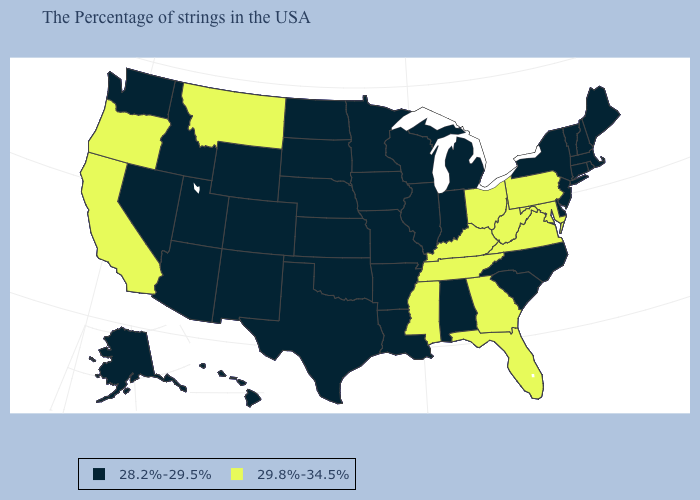What is the value of Nebraska?
Write a very short answer. 28.2%-29.5%. Among the states that border South Dakota , does Montana have the highest value?
Write a very short answer. Yes. Does Pennsylvania have the lowest value in the Northeast?
Give a very brief answer. No. Does Arizona have the highest value in the USA?
Short answer required. No. Among the states that border Florida , does Alabama have the lowest value?
Quick response, please. Yes. What is the value of Delaware?
Be succinct. 28.2%-29.5%. What is the value of Montana?
Give a very brief answer. 29.8%-34.5%. Name the states that have a value in the range 28.2%-29.5%?
Write a very short answer. Maine, Massachusetts, Rhode Island, New Hampshire, Vermont, Connecticut, New York, New Jersey, Delaware, North Carolina, South Carolina, Michigan, Indiana, Alabama, Wisconsin, Illinois, Louisiana, Missouri, Arkansas, Minnesota, Iowa, Kansas, Nebraska, Oklahoma, Texas, South Dakota, North Dakota, Wyoming, Colorado, New Mexico, Utah, Arizona, Idaho, Nevada, Washington, Alaska, Hawaii. Does South Carolina have the highest value in the USA?
Answer briefly. No. Name the states that have a value in the range 29.8%-34.5%?
Short answer required. Maryland, Pennsylvania, Virginia, West Virginia, Ohio, Florida, Georgia, Kentucky, Tennessee, Mississippi, Montana, California, Oregon. Name the states that have a value in the range 28.2%-29.5%?
Write a very short answer. Maine, Massachusetts, Rhode Island, New Hampshire, Vermont, Connecticut, New York, New Jersey, Delaware, North Carolina, South Carolina, Michigan, Indiana, Alabama, Wisconsin, Illinois, Louisiana, Missouri, Arkansas, Minnesota, Iowa, Kansas, Nebraska, Oklahoma, Texas, South Dakota, North Dakota, Wyoming, Colorado, New Mexico, Utah, Arizona, Idaho, Nevada, Washington, Alaska, Hawaii. What is the value of Mississippi?
Concise answer only. 29.8%-34.5%. 